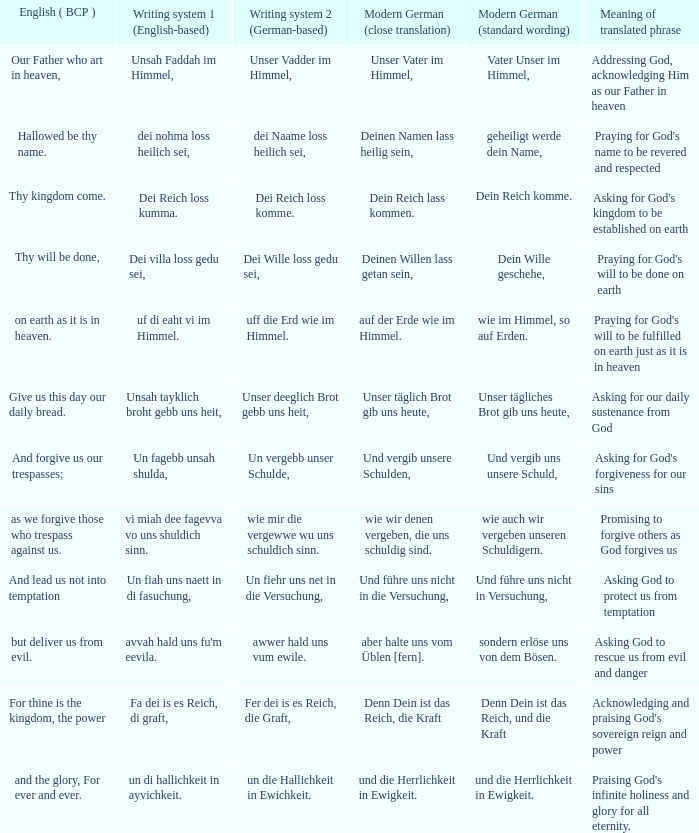What is the modern german standard wording for the german based writing system 2 phrase "wie mir die vergewwe wu uns schuldich sinn."? Wie auch wir vergeben unseren schuldigern. 